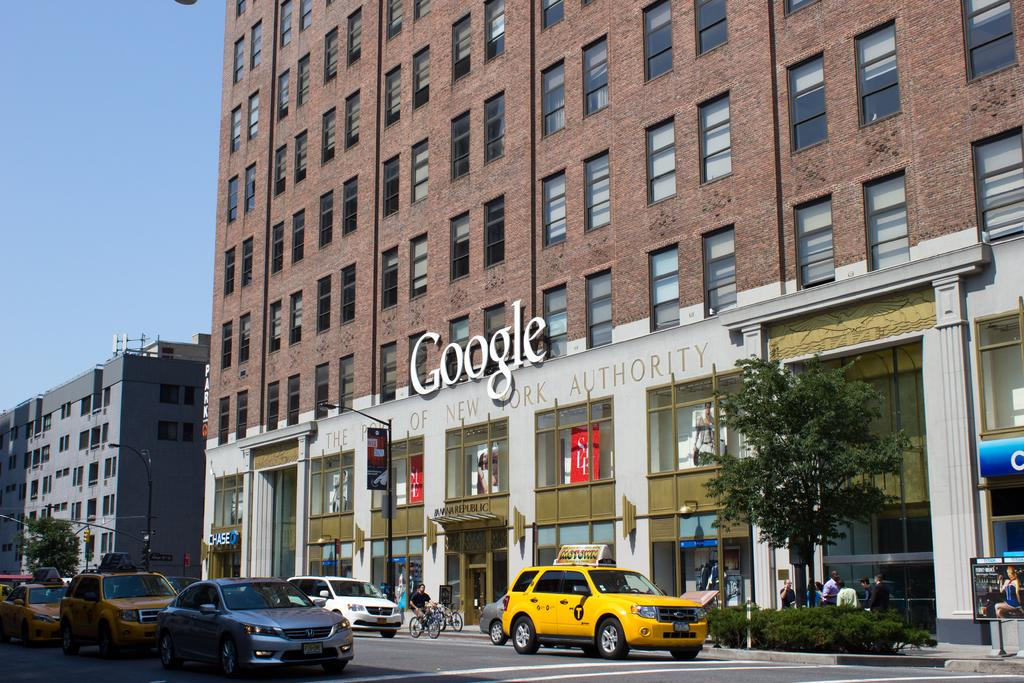<image>
Describe the image concisely. The outside of a brick building with a large Google sign 